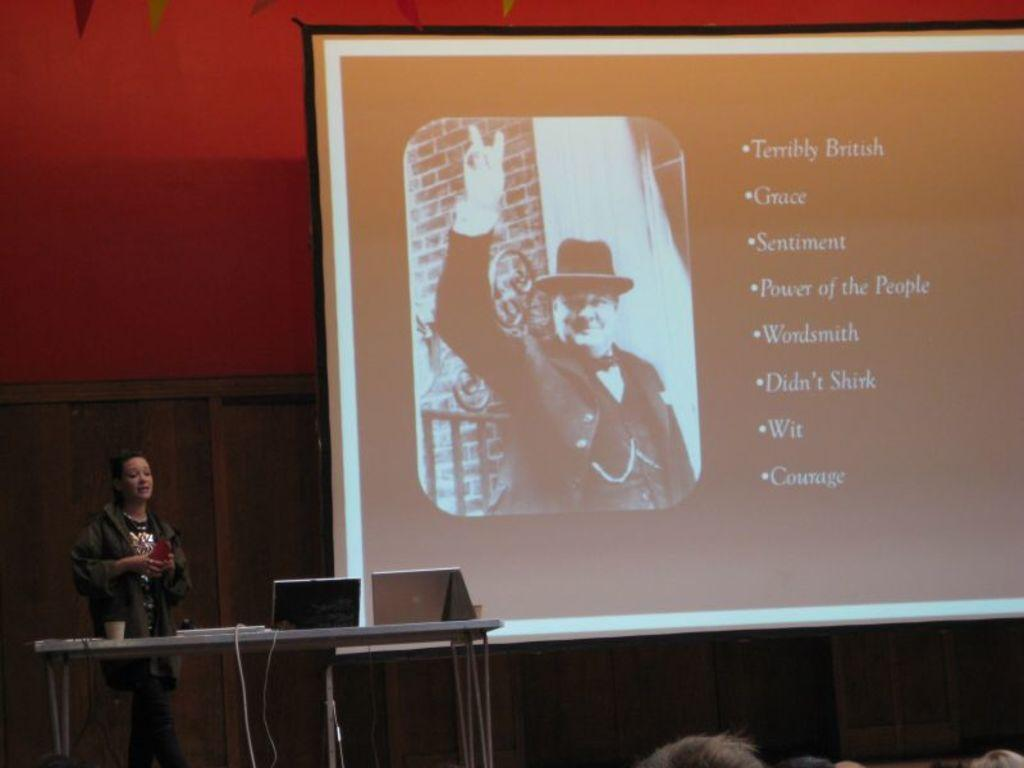What is the woman doing in the image? The woman is standing in the image. What is in front of the woman? There is a table in front of the woman. What items can be seen on the table? There are laptops and a cup on the table. What can be seen in the background of the image? There is a wall, a screen, and a wooden object in the background of the image. What type of pies is the woman baking in the image? There is no indication in the image that the woman is baking pies, and therefore no such activity can be observed. 